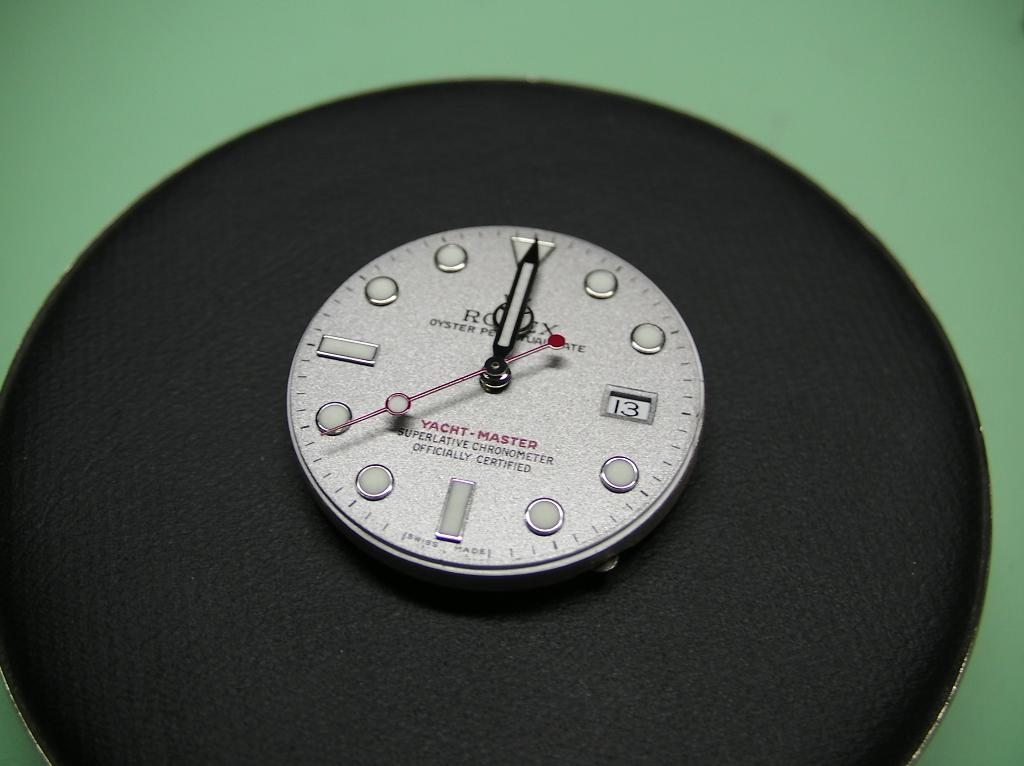<image>
Share a concise interpretation of the image provided. Yacht Master Rolex is engraved onto the face of this timepiece. 